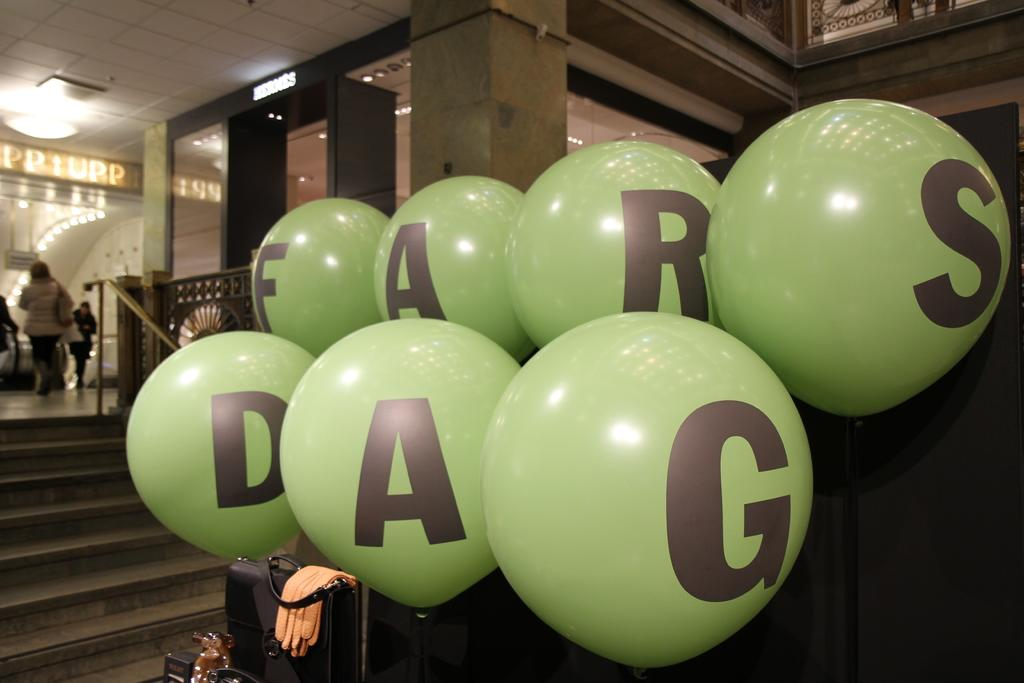What objects are present in the image that are filled with air? There are balloons in the image. What is on the ground near the people in the image? There is a suitcase on the ground in the image. Can you describe the people in the image? There are people standing in the image. Can you tell me how many rays are swimming in the harbor in the image? There is no harbor or rays present in the image; it features balloons, a suitcase, and people standing. 